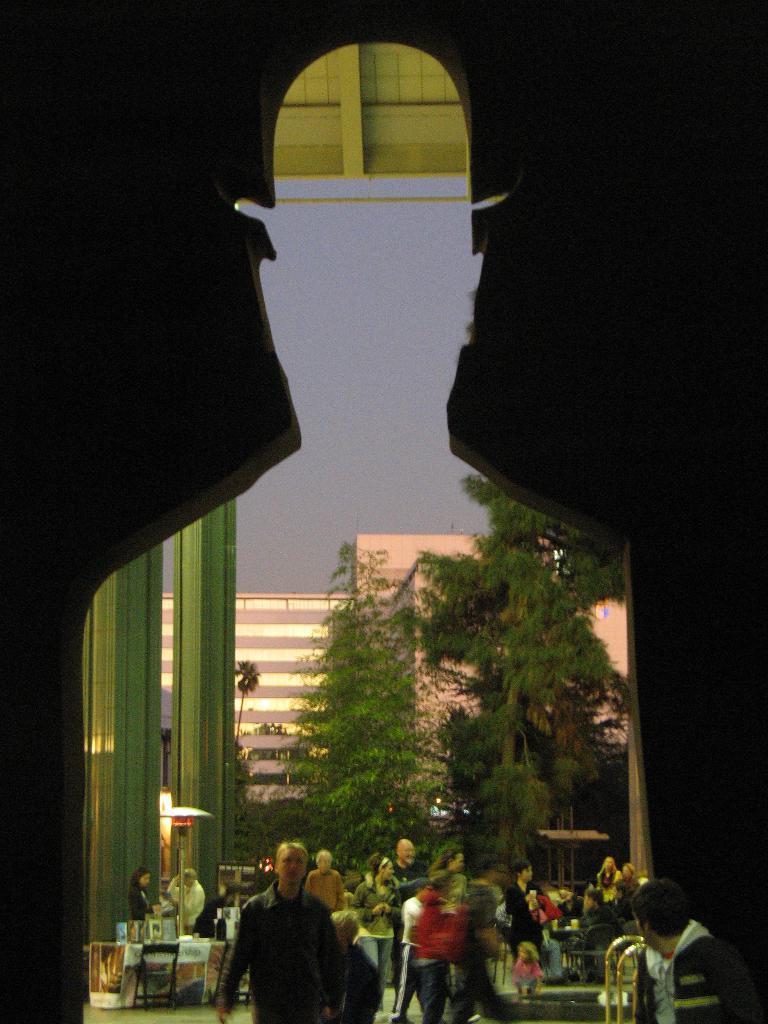Could you give a brief overview of what you see in this image? At the bottom of the image there are people walking on the grass. In the background of the image there are buildings,trees. In the foreground of the image there is a depiction of a person. 